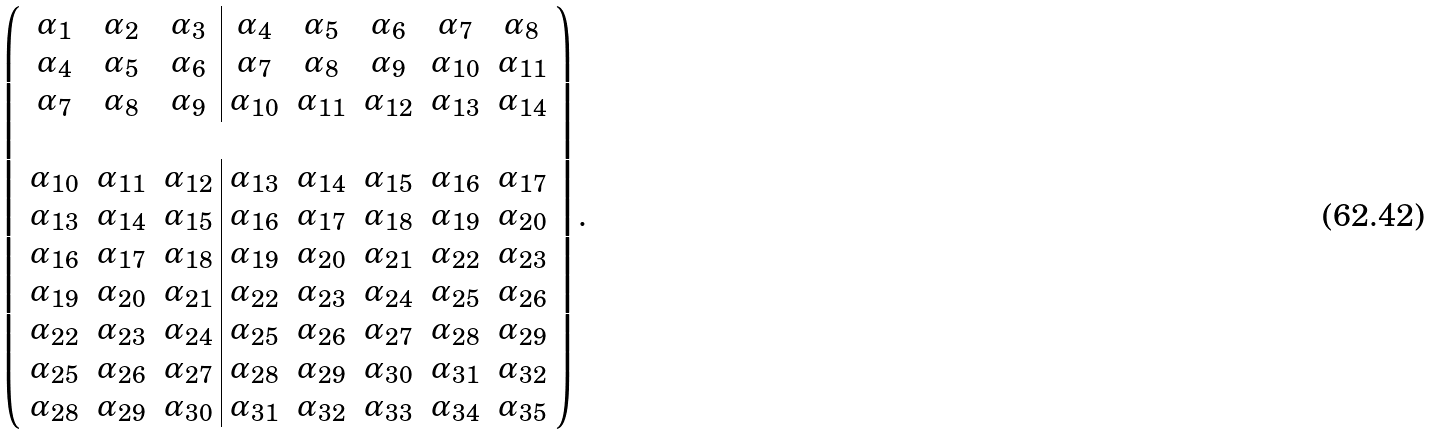Convert formula to latex. <formula><loc_0><loc_0><loc_500><loc_500>\left ( \begin{array} { c c c | c c c c c } \alpha _ { 1 } & \alpha _ { 2 } & \alpha _ { 3 } & \alpha _ { 4 } & \alpha _ { 5 } & \alpha _ { 6 } & \alpha _ { 7 } & \alpha _ { 8 } \\ \alpha _ { 4 } & \alpha _ { 5 } & \alpha _ { 6 } & \alpha _ { 7 } & \alpha _ { 8 } & \alpha _ { 9 } & \alpha _ { 1 0 } & \alpha _ { 1 1 } \\ \alpha _ { 7 } & \alpha _ { 8 } & \alpha _ { 9 } & \alpha _ { 1 0 } & \alpha _ { 1 1 } & \alpha _ { 1 2 } & \alpha _ { 1 3 } & \alpha _ { 1 4 } \\ \\ \alpha _ { 1 0 } & \alpha _ { 1 1 } & \alpha _ { 1 2 } & \alpha _ { 1 3 } & \alpha _ { 1 4 } & \alpha _ { 1 5 } & \alpha _ { 1 6 } & \alpha _ { 1 7 } \\ \alpha _ { 1 3 } & \alpha _ { 1 4 } & \alpha _ { 1 5 } & \alpha _ { 1 6 } & \alpha _ { 1 7 } & \alpha _ { 1 8 } & \alpha _ { 1 9 } & \alpha _ { 2 0 } \\ \alpha _ { 1 6 } & \alpha _ { 1 7 } & \alpha _ { 1 8 } & \alpha _ { 1 9 } & \alpha _ { 2 0 } & \alpha _ { 2 1 } & \alpha _ { 2 2 } & \alpha _ { 2 3 } \\ \alpha _ { 1 9 } & \alpha _ { 2 0 } & \alpha _ { 2 1 } & \alpha _ { 2 2 } & \alpha _ { 2 3 } & \alpha _ { 2 4 } & \alpha _ { 2 5 } & \alpha _ { 2 6 } \\ \alpha _ { 2 2 } & \alpha _ { 2 3 } & \alpha _ { 2 4 } & \alpha _ { 2 5 } & \alpha _ { 2 6 } & \alpha _ { 2 7 } & \alpha _ { 2 8 } & \alpha _ { 2 9 } \\ \alpha _ { 2 5 } & \alpha _ { 2 6 } & \alpha _ { 2 7 } & \alpha _ { 2 8 } & \alpha _ { 2 9 } & \alpha _ { 3 0 } & \alpha _ { 3 1 } & \alpha _ { 3 2 } \\ \alpha _ { 2 8 } & \alpha _ { 2 9 } & \alpha _ { 3 0 } & \alpha _ { 3 1 } & \alpha _ { 3 2 } & \alpha _ { 3 3 } & \alpha _ { 3 4 } & \alpha _ { 3 5 } \\ \end{array} \right ) .</formula> 